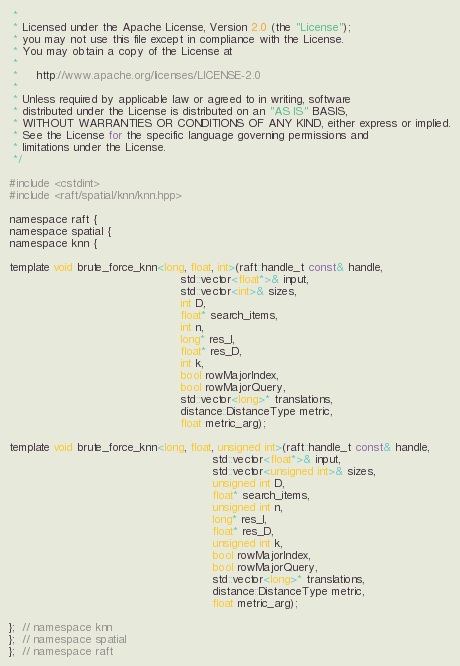Convert code to text. <code><loc_0><loc_0><loc_500><loc_500><_Cuda_> *
 * Licensed under the Apache License, Version 2.0 (the "License");
 * you may not use this file except in compliance with the License.
 * You may obtain a copy of the License at
 *
 *     http://www.apache.org/licenses/LICENSE-2.0
 *
 * Unless required by applicable law or agreed to in writing, software
 * distributed under the License is distributed on an "AS IS" BASIS,
 * WITHOUT WARRANTIES OR CONDITIONS OF ANY KIND, either express or implied.
 * See the License for the specific language governing permissions and
 * limitations under the License.
 */

#include <cstdint>
#include <raft/spatial/knn/knn.hpp>

namespace raft {
namespace spatial {
namespace knn {

template void brute_force_knn<long, float, int>(raft::handle_t const& handle,
                                                std::vector<float*>& input,
                                                std::vector<int>& sizes,
                                                int D,
                                                float* search_items,
                                                int n,
                                                long* res_I,
                                                float* res_D,
                                                int k,
                                                bool rowMajorIndex,
                                                bool rowMajorQuery,
                                                std::vector<long>* translations,
                                                distance::DistanceType metric,
                                                float metric_arg);

template void brute_force_knn<long, float, unsigned int>(raft::handle_t const& handle,
                                                         std::vector<float*>& input,
                                                         std::vector<unsigned int>& sizes,
                                                         unsigned int D,
                                                         float* search_items,
                                                         unsigned int n,
                                                         long* res_I,
                                                         float* res_D,
                                                         unsigned int k,
                                                         bool rowMajorIndex,
                                                         bool rowMajorQuery,
                                                         std::vector<long>* translations,
                                                         distance::DistanceType metric,
                                                         float metric_arg);

};  // namespace knn
};  // namespace spatial
};  // namespace raft
</code> 